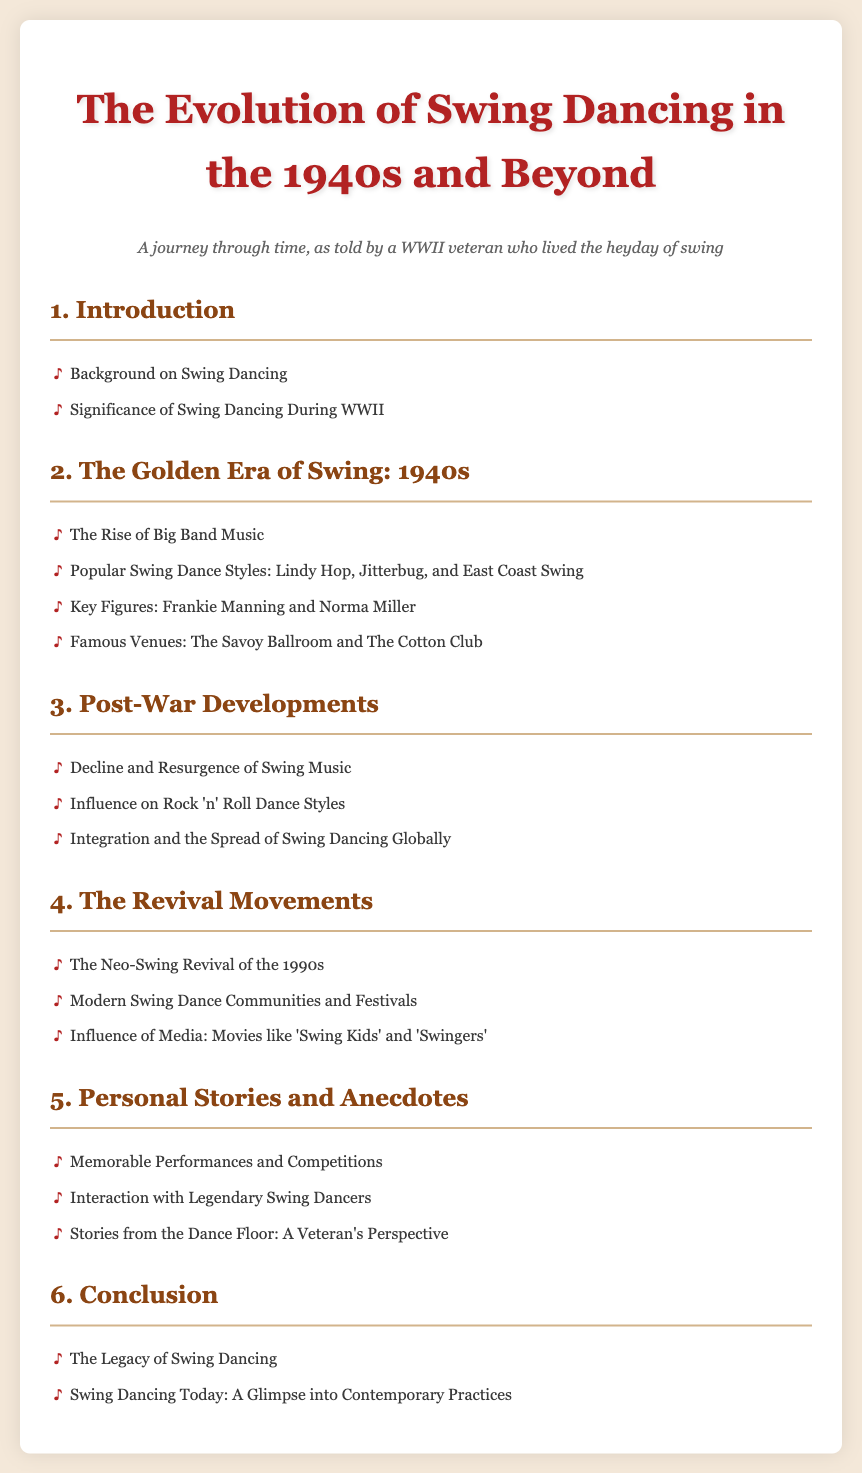What is the title of the document? The title is displayed prominently at the top of the page and reflects the main focus of the content.
Answer: The Evolution of Swing Dancing in the 1940s and Beyond Who are the key figures mentioned in the document? Key figures are listed under the section about the Golden Era of Swing and highlight important contributors to swing dancing.
Answer: Frankie Manning and Norma Miller What was one famous venue for swing dancing during the 1940s? The document lists famous venues in the section about the Golden Era, indicating important locations for the dance.
Answer: The Savoy Ballroom Which dance styles are mentioned as popular during the 1940s? The document details various dance styles under the same section, showcasing the diversity of swing dancing.
Answer: Lindy Hop, Jitterbug, and East Coast Swing What revival movement is discussed in the 1990s? The document outlines movements that brought swing dancing back into the spotlight, focusing on a specific decade.
Answer: Neo-Swing Revival How does the document describe the influence of media on swing dancing? It examines the impact of films in the revival sections, showing how popular culture affected swing dance.
Answer: Movies like 'Swing Kids' and 'Swingers' What does the conclusion address regarding swing dancing today? The conclusion summarizes contemporary practices and the enduring legacy of swing dancing.
Answer: A Glimpse into Contemporary Practices 